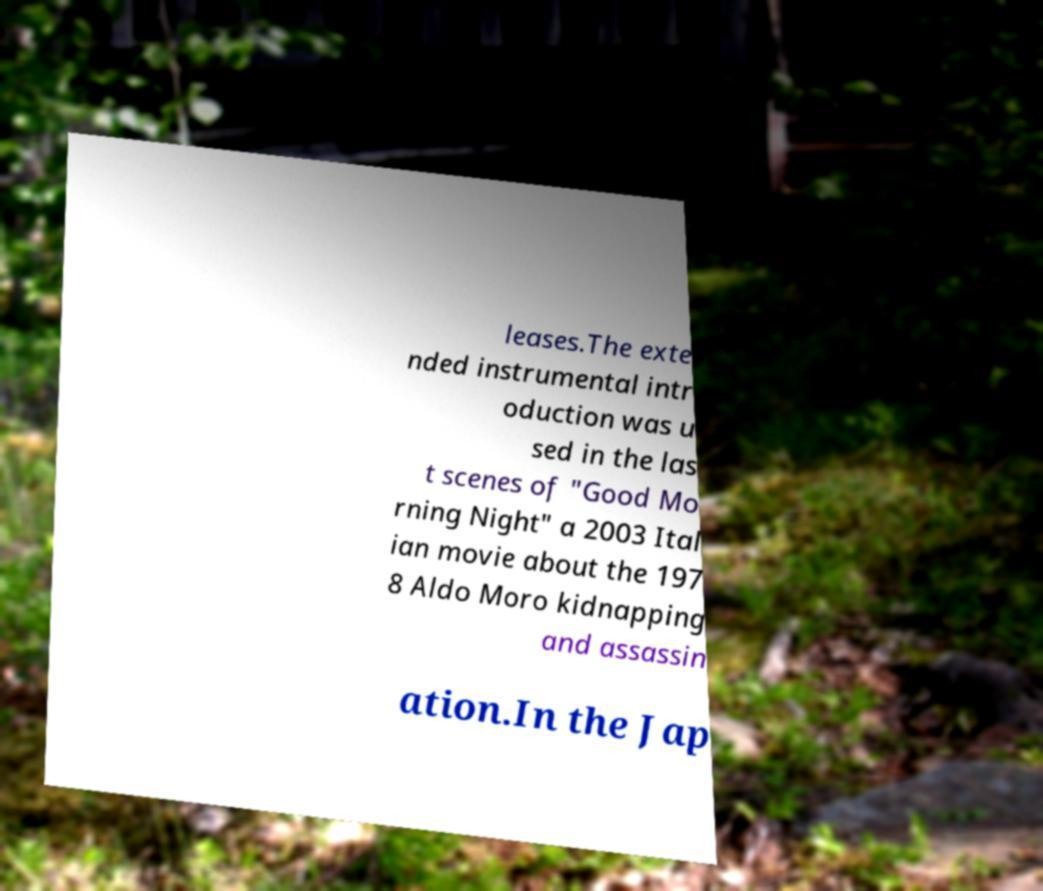Could you assist in decoding the text presented in this image and type it out clearly? leases.The exte nded instrumental intr oduction was u sed in the las t scenes of "Good Mo rning Night" a 2003 Ital ian movie about the 197 8 Aldo Moro kidnapping and assassin ation.In the Jap 